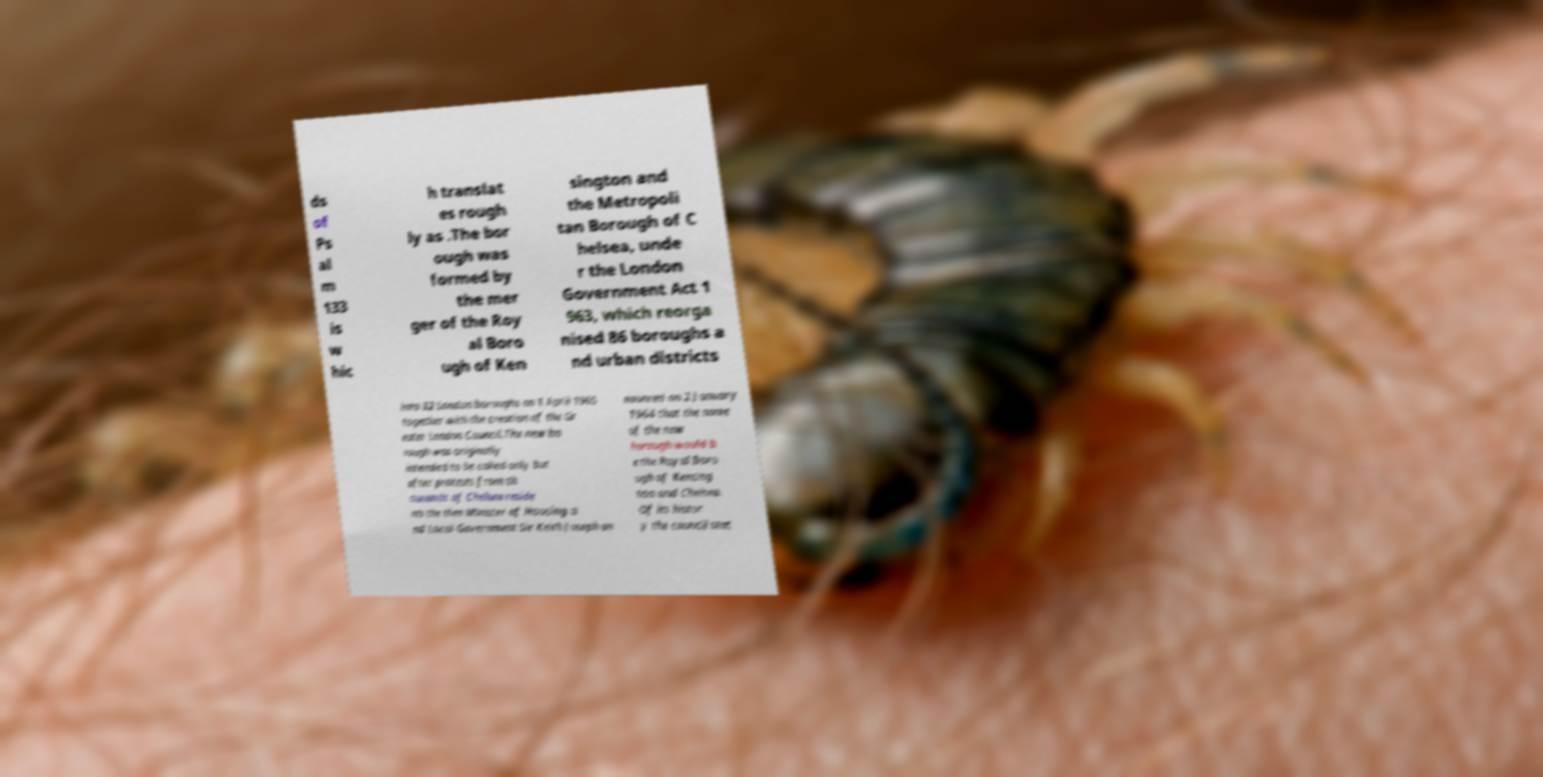Could you assist in decoding the text presented in this image and type it out clearly? ds of Ps al m 133 is w hic h translat es rough ly as .The bor ough was formed by the mer ger of the Roy al Boro ugh of Ken sington and the Metropoli tan Borough of C helsea, unde r the London Government Act 1 963, which reorga nised 86 boroughs a nd urban districts into 32 London boroughs on 1 April 1965 together with the creation of the Gr eater London Council.The new bo rough was originally intended to be called only but after protests from th ousands of Chelsea reside nts the then Minister of Housing a nd Local Government Sir Keith Joseph an nounced on 2 January 1964 that the name of the new borough would b e the Royal Boro ugh of Kensing ton and Chelsea. Of its histor y the council stat 